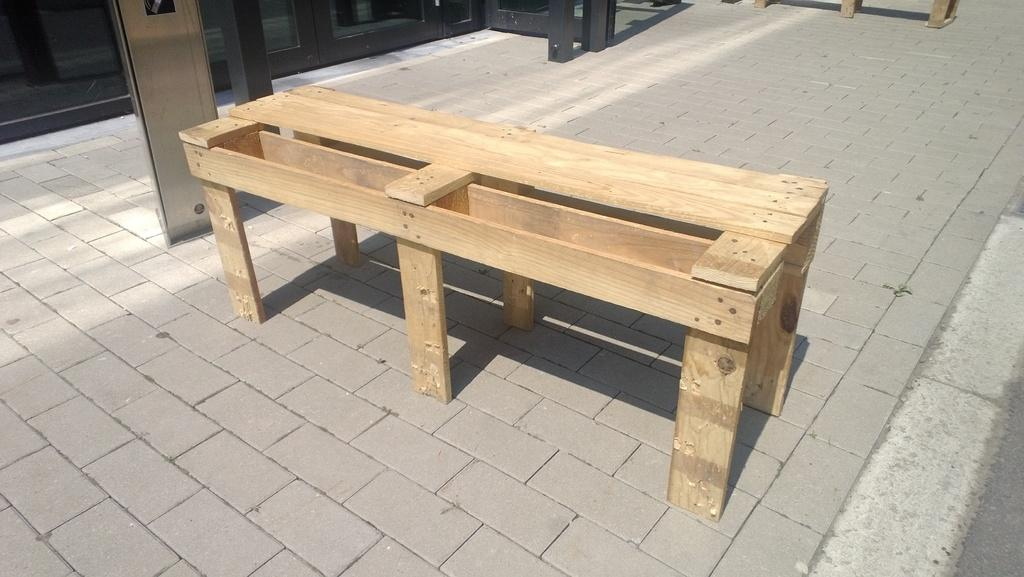What type of structure is on the platform in the image? There is a bench on the platform in the image. What else can be seen on the platform besides the bench? There are poles in the image. What is the main subject of the image? The main subject of the image is a train. What is the color of the train in the image? The train is black in color. Can you see any monkeys climbing the poles in the image? There are no monkeys present in the image; it features a bench, poles, and a black train. Is there any quicksand visible on the platform in the image? There is no quicksand present in the image; it features a bench, poles, and a black train. 